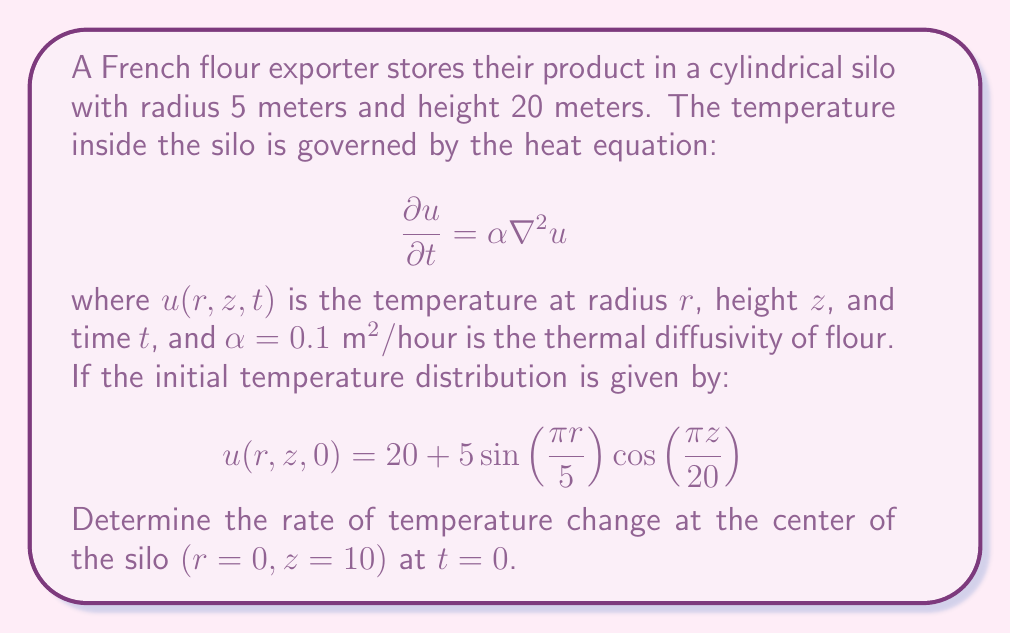Provide a solution to this math problem. To solve this problem, we need to use the heat equation and the given initial temperature distribution. Let's approach this step-by-step:

1) The heat equation in cylindrical coordinates is:

   $$\frac{\partial u}{\partial t} = \alpha \left(\frac{1}{r}\frac{\partial}{\partial r}\left(r\frac{\partial u}{\partial r}\right) + \frac{\partial^2 u}{\partial z^2}\right)$$

2) We need to calculate $\frac{\partial u}{\partial t}$ at $r=0$, $z=10$, and $t=0$. This is equal to $\alpha$ times the Laplacian of $u$ at that point.

3) Let's calculate the partial derivatives of $u$ with respect to $r$ and $z$:

   $$\frac{\partial u}{\partial r} = 5\frac{\pi}{5}\cos(\frac{\pi r}{5})\cos(\frac{\pi z}{20}) = \pi\cos(\frac{\pi r}{5})\cos(\frac{\pi z}{20})$$
   
   $$\frac{\partial^2 u}{\partial r^2} = -\pi^2\frac{1}{5}\sin(\frac{\pi r}{5})\cos(\frac{\pi z}{20})$$
   
   $$\frac{\partial^2 u}{\partial z^2} = -5\frac{\pi^2}{400}\sin(\frac{\pi r}{5})\cos(\frac{\pi z}{20})$$

4) At $r=0$ and $z=10$:

   $$\frac{\partial u}{\partial r} = \pi\cos(0)\cos(\frac{\pi}{2}) = 0$$
   
   $$\frac{\partial^2 u}{\partial r^2} = -\pi^2\frac{1}{5}\sin(0)\cos(\frac{\pi}{2}) = 0$$
   
   $$\frac{\partial^2 u}{\partial z^2} = -5\frac{\pi^2}{400}\sin(0)\cos(\frac{\pi}{2}) = 0$$

5) The Laplacian in cylindrical coordinates at $r=0$ simplifies to:

   $$\nabla^2 u = 2\frac{\partial^2 u}{\partial r^2} + \frac{\partial^2 u}{\partial z^2} = 0$$

6) Therefore, the rate of temperature change at the center of the silo at $t=0$ is:

   $$\frac{\partial u}{\partial t} = \alpha \nabla^2 u = 0.1 \cdot 0 = 0 \text{ °C/hour}$$
Answer: $0 \text{ °C/hour}$ 